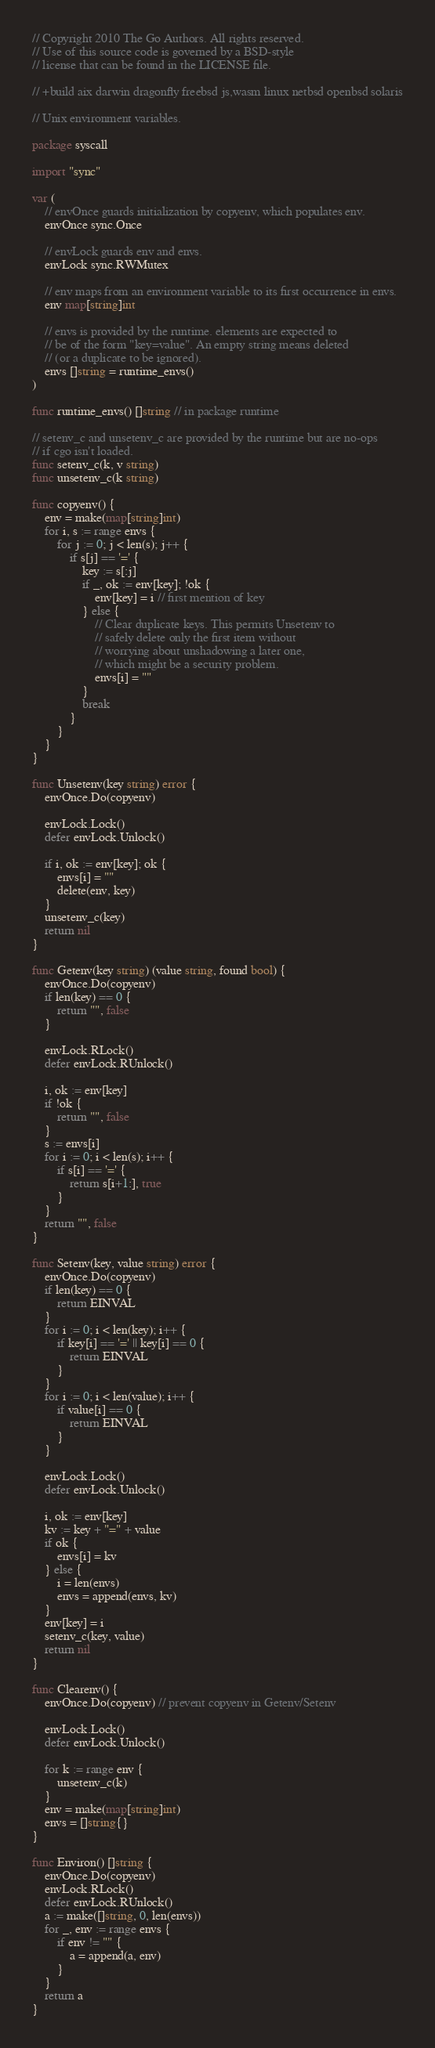Convert code to text. <code><loc_0><loc_0><loc_500><loc_500><_Go_>// Copyright 2010 The Go Authors. All rights reserved.
// Use of this source code is governed by a BSD-style
// license that can be found in the LICENSE file.

// +build aix darwin dragonfly freebsd js,wasm linux netbsd openbsd solaris

// Unix environment variables.

package syscall

import "sync"

var (
	// envOnce guards initialization by copyenv, which populates env.
	envOnce sync.Once

	// envLock guards env and envs.
	envLock sync.RWMutex

	// env maps from an environment variable to its first occurrence in envs.
	env map[string]int

	// envs is provided by the runtime. elements are expected to
	// be of the form "key=value". An empty string means deleted
	// (or a duplicate to be ignored).
	envs []string = runtime_envs()
)

func runtime_envs() []string // in package runtime

// setenv_c and unsetenv_c are provided by the runtime but are no-ops
// if cgo isn't loaded.
func setenv_c(k, v string)
func unsetenv_c(k string)

func copyenv() {
	env = make(map[string]int)
	for i, s := range envs {
		for j := 0; j < len(s); j++ {
			if s[j] == '=' {
				key := s[:j]
				if _, ok := env[key]; !ok {
					env[key] = i // first mention of key
				} else {
					// Clear duplicate keys. This permits Unsetenv to
					// safely delete only the first item without
					// worrying about unshadowing a later one,
					// which might be a security problem.
					envs[i] = ""
				}
				break
			}
		}
	}
}

func Unsetenv(key string) error {
	envOnce.Do(copyenv)

	envLock.Lock()
	defer envLock.Unlock()

	if i, ok := env[key]; ok {
		envs[i] = ""
		delete(env, key)
	}
	unsetenv_c(key)
	return nil
}

func Getenv(key string) (value string, found bool) {
	envOnce.Do(copyenv)
	if len(key) == 0 {
		return "", false
	}

	envLock.RLock()
	defer envLock.RUnlock()

	i, ok := env[key]
	if !ok {
		return "", false
	}
	s := envs[i]
	for i := 0; i < len(s); i++ {
		if s[i] == '=' {
			return s[i+1:], true
		}
	}
	return "", false
}

func Setenv(key, value string) error {
	envOnce.Do(copyenv)
	if len(key) == 0 {
		return EINVAL
	}
	for i := 0; i < len(key); i++ {
		if key[i] == '=' || key[i] == 0 {
			return EINVAL
		}
	}
	for i := 0; i < len(value); i++ {
		if value[i] == 0 {
			return EINVAL
		}
	}

	envLock.Lock()
	defer envLock.Unlock()

	i, ok := env[key]
	kv := key + "=" + value
	if ok {
		envs[i] = kv
	} else {
		i = len(envs)
		envs = append(envs, kv)
	}
	env[key] = i
	setenv_c(key, value)
	return nil
}

func Clearenv() {
	envOnce.Do(copyenv) // prevent copyenv in Getenv/Setenv

	envLock.Lock()
	defer envLock.Unlock()

	for k := range env {
		unsetenv_c(k)
	}
	env = make(map[string]int)
	envs = []string{}
}

func Environ() []string {
	envOnce.Do(copyenv)
	envLock.RLock()
	defer envLock.RUnlock()
	a := make([]string, 0, len(envs))
	for _, env := range envs {
		if env != "" {
			a = append(a, env)
		}
	}
	return a
}
</code> 